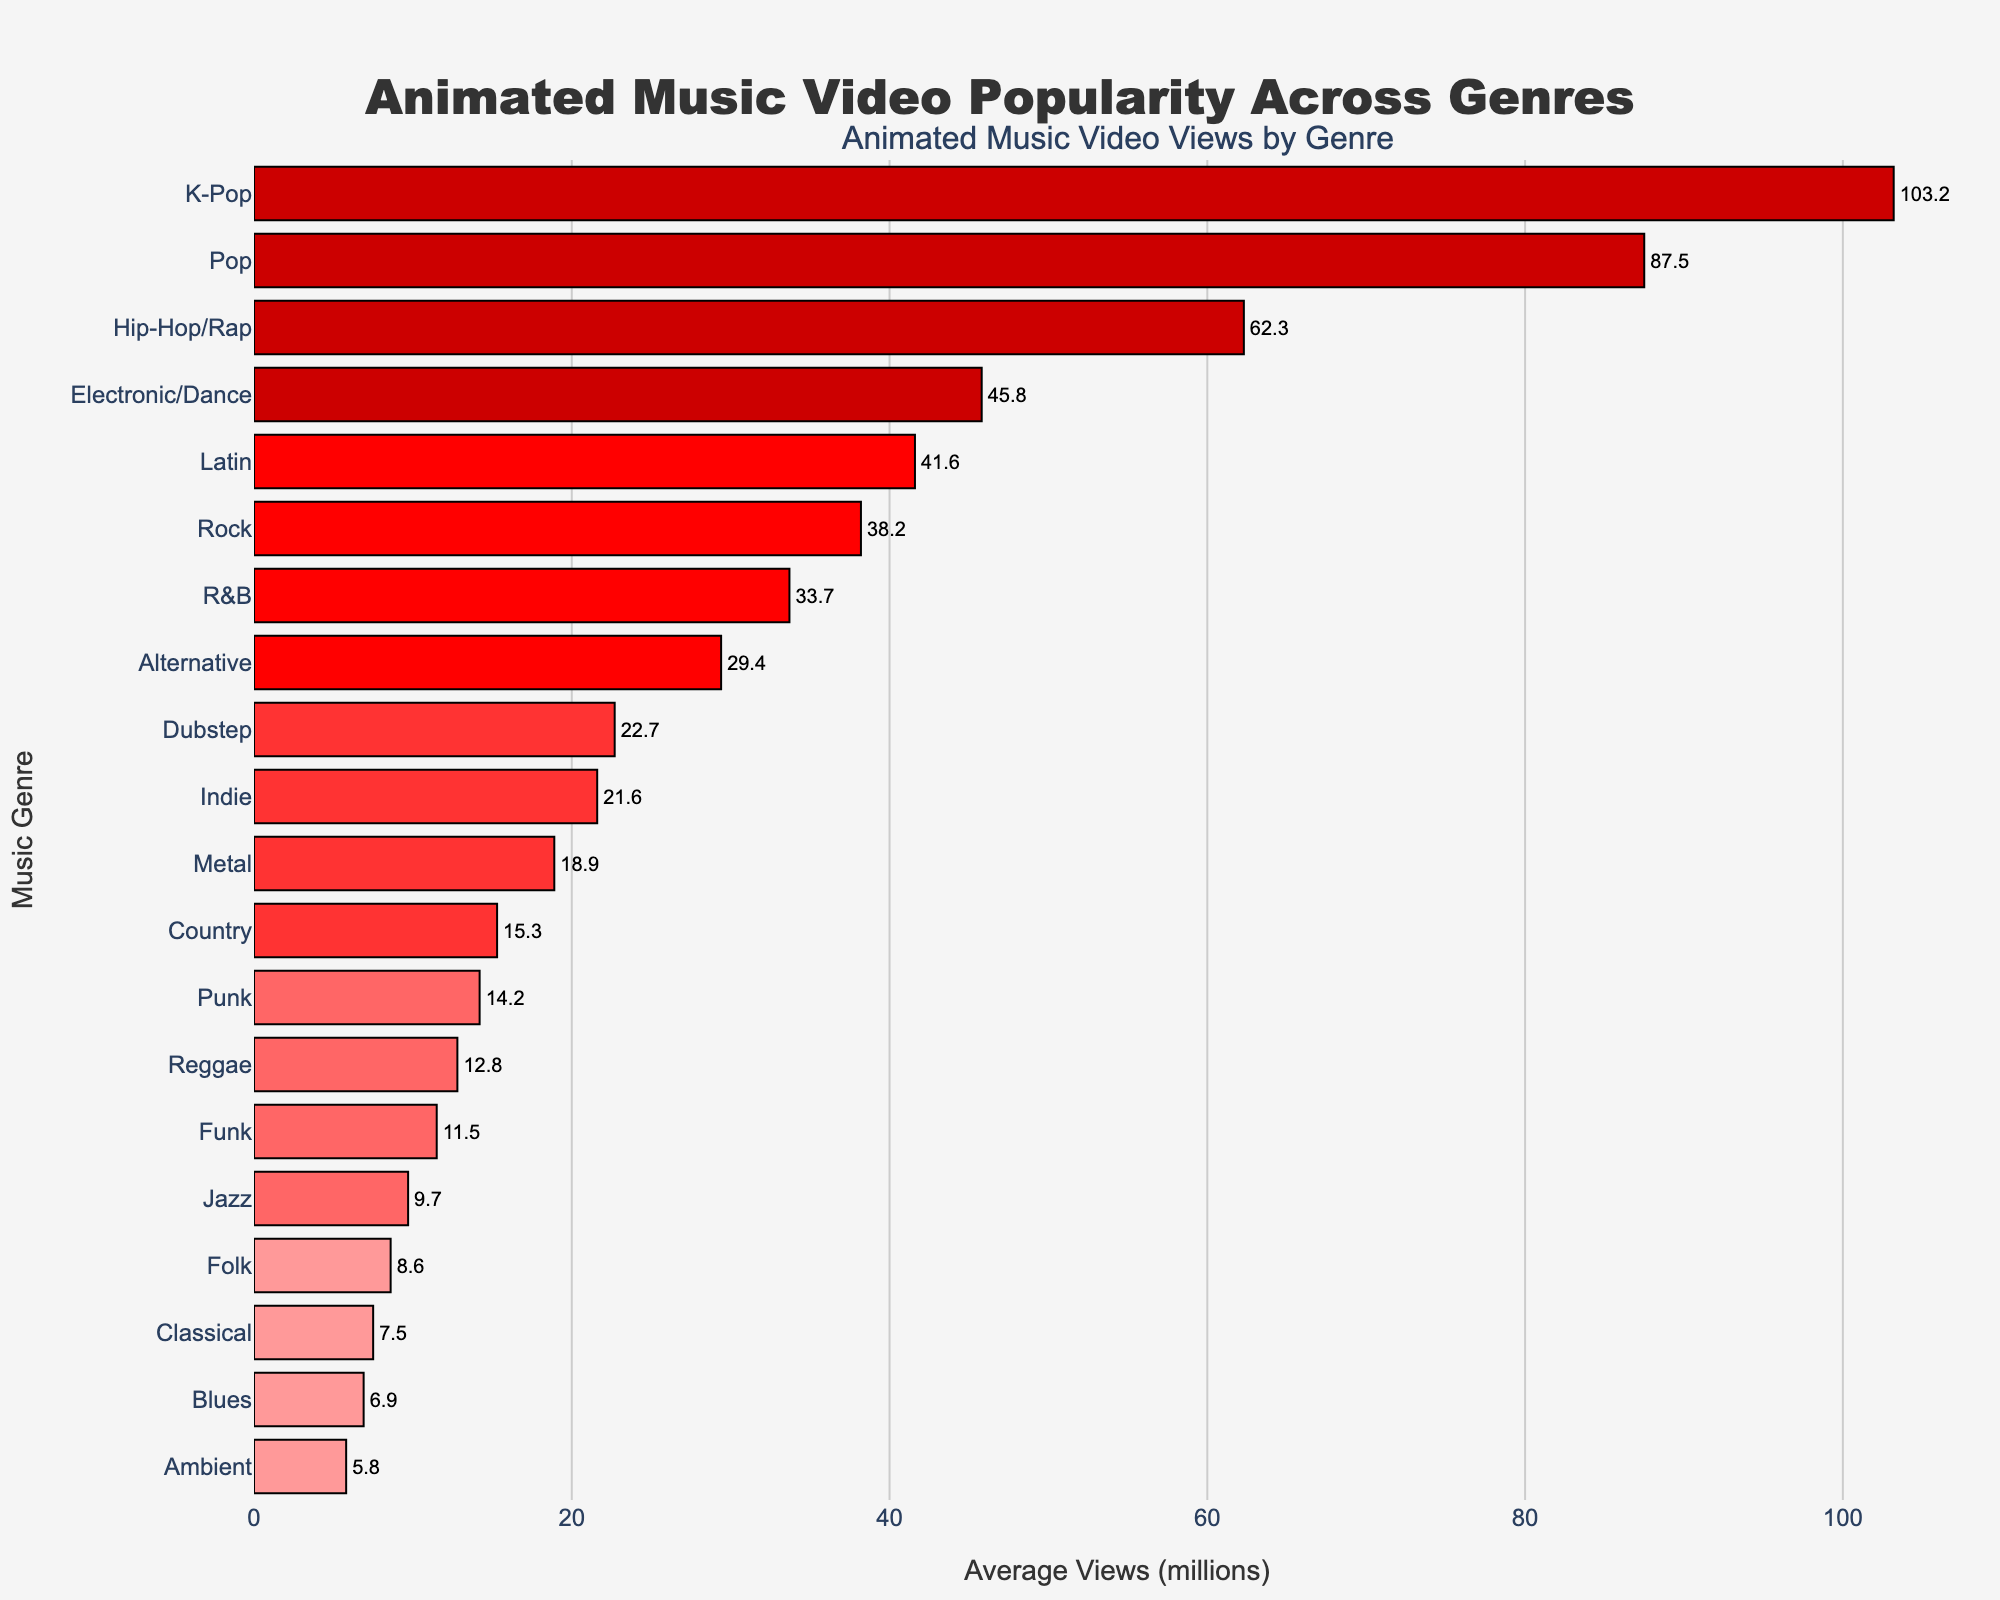Which genre has the highest average views for animated music videos? The bar chart shows that K-Pop has the highest average views among all genres, as indicated by the longest bar.
Answer: K-Pop Which genre has the lowest average views for animated music videos? The bar chart shows that Ambient has the lowest average views among all genres, as it has the shortest bar.
Answer: Ambient How much higher are the average views for Pop compared to Rock? According to the bar chart, Pop has 87.5 million views and Rock has 38.2 million views. The difference is calculated as 87.5 - 38.2 = 49.3 million views.
Answer: 49.3 million Which genres have average views less than 20 million? From the chart, the genres with bars less than 20 million views are Metal, Jazz, Classical, Country, Reggae, Folk, Punk, Funk, and Blues.
Answer: Metal, Jazz, Classical, Country, Reggae, Folk, Punk, Funk, Blues What is the average view count for genres with over 50 million views? The genres with over 50 million views are K-Pop (103.2), Pop (87.5), and Hip-Hop/Rap (62.3). The average is calculated as (103.2 + 87.5 + 62.3) / 3 = 251 / 3 ≈ 83.7 million views.
Answer: 83.7 million How does the average view count for Electronic/Dance compare to Hip-Hop/Rap and Latin? The bar chart shows Electronic/Dance at 45.8 million, Hip-Hop/Rap at 62.3 million, and Latin at 41.6 million. Electronic/Dance has a higher average view count than Latin but lower than Hip-Hop/Rap.
Answer: Higher than Latin, lower than Hip-Hop/Rap Are the average views for Funk closer to Blues or Country? The average views for Funk are 11.5 million. Comparing this to Blues (6.9 million) and Country (15.3 million), 11.5 is closer to the 15.3 million views of Country.
Answer: Country How much more popular is the highest viewed genre compared to the least viewed genre? K-Pop has the highest views at 103.2 million and Ambient has the lowest at 5.8 million. The difference is 103.2 - 5.8 = 97.4 million views.
Answer: 97.4 million Which genres fall between 10 million and 20 million average views? The chart shows that Country, Reggae, Punk, and Funk have average views falling between 10 million and 20 million.
Answer: Country, Reggae, Punk, Funk Among genres with less than 30 million views, which one has the highest average? Within this group, Alternative has the highest average views at 29.4 million.
Answer: Alternative 